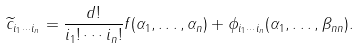Convert formula to latex. <formula><loc_0><loc_0><loc_500><loc_500>\widetilde { c } _ { i _ { 1 } \cdots i _ { n } } = \frac { d ! } { i _ { 1 } ! \cdots i _ { n } ! } f ( \alpha _ { 1 } , \dots , \alpha _ { n } ) + \phi _ { i _ { 1 } \cdots i _ { n } } ( \alpha _ { 1 } , \dots , \beta _ { n n } ) .</formula> 